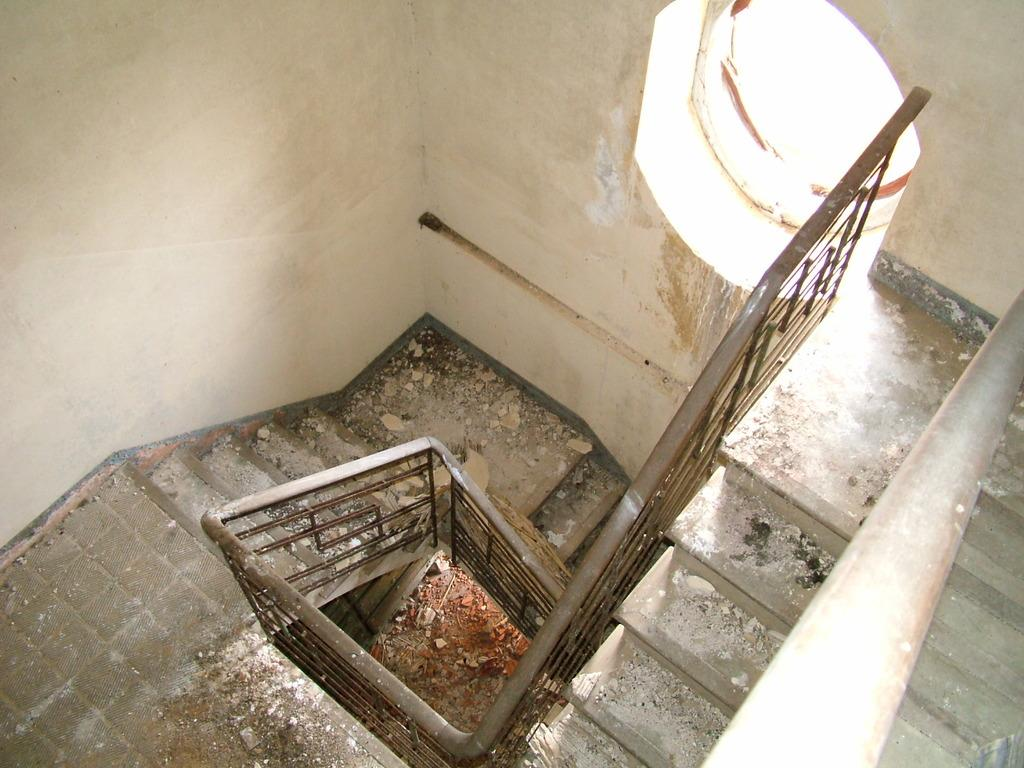What type of structure is present in the image? There is a staircase in the image. Can you describe the condition of the staircase? The staircase has stones and scrap on it. What other object can be seen in the image? There is a metal fence in the image. What is the state of the wall in the image? There is a hole in a wall in the image. What type of spark can be seen coming from the aunt's hand in the image? There is no aunt or spark present in the image. 